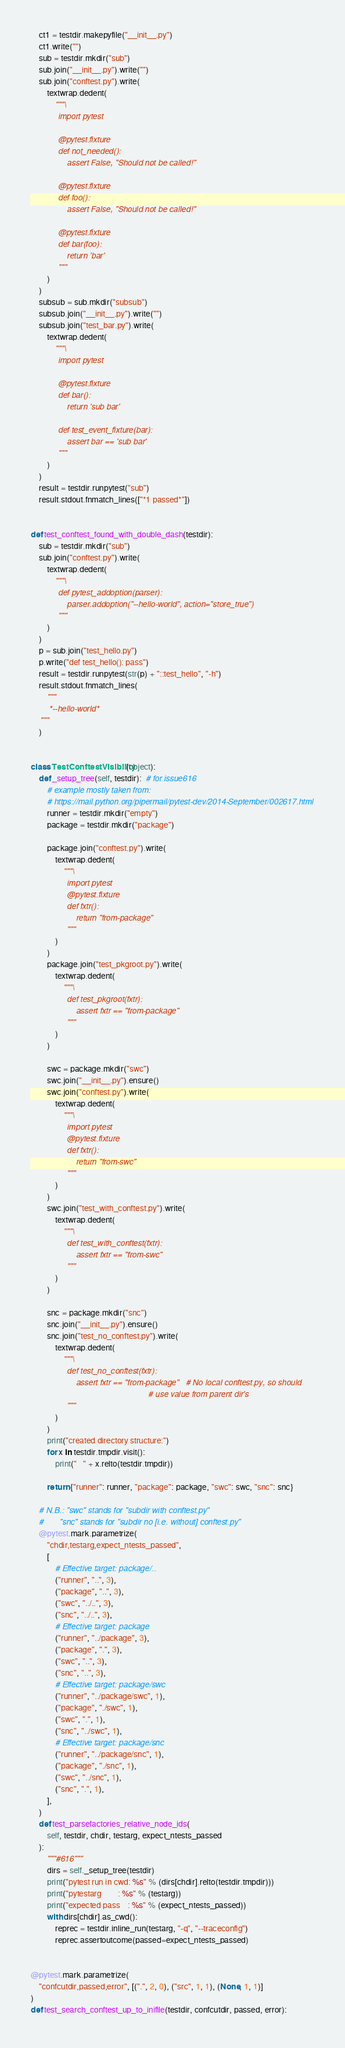Convert code to text. <code><loc_0><loc_0><loc_500><loc_500><_Python_>    ct1 = testdir.makepyfile("__init__.py")
    ct1.write("")
    sub = testdir.mkdir("sub")
    sub.join("__init__.py").write("")
    sub.join("conftest.py").write(
        textwrap.dedent(
            """\
            import pytest

            @pytest.fixture
            def not_needed():
                assert False, "Should not be called!"

            @pytest.fixture
            def foo():
                assert False, "Should not be called!"

            @pytest.fixture
            def bar(foo):
                return 'bar'
            """
        )
    )
    subsub = sub.mkdir("subsub")
    subsub.join("__init__.py").write("")
    subsub.join("test_bar.py").write(
        textwrap.dedent(
            """\
            import pytest

            @pytest.fixture
            def bar():
                return 'sub bar'

            def test_event_fixture(bar):
                assert bar == 'sub bar'
            """
        )
    )
    result = testdir.runpytest("sub")
    result.stdout.fnmatch_lines(["*1 passed*"])


def test_conftest_found_with_double_dash(testdir):
    sub = testdir.mkdir("sub")
    sub.join("conftest.py").write(
        textwrap.dedent(
            """\
            def pytest_addoption(parser):
                parser.addoption("--hello-world", action="store_true")
            """
        )
    )
    p = sub.join("test_hello.py")
    p.write("def test_hello(): pass")
    result = testdir.runpytest(str(p) + "::test_hello", "-h")
    result.stdout.fnmatch_lines(
        """
        *--hello-world*
    """
    )


class TestConftestVisibility(object):
    def _setup_tree(self, testdir):  # for issue616
        # example mostly taken from:
        # https://mail.python.org/pipermail/pytest-dev/2014-September/002617.html
        runner = testdir.mkdir("empty")
        package = testdir.mkdir("package")

        package.join("conftest.py").write(
            textwrap.dedent(
                """\
                import pytest
                @pytest.fixture
                def fxtr():
                    return "from-package"
                """
            )
        )
        package.join("test_pkgroot.py").write(
            textwrap.dedent(
                """\
                def test_pkgroot(fxtr):
                    assert fxtr == "from-package"
                """
            )
        )

        swc = package.mkdir("swc")
        swc.join("__init__.py").ensure()
        swc.join("conftest.py").write(
            textwrap.dedent(
                """\
                import pytest
                @pytest.fixture
                def fxtr():
                    return "from-swc"
                """
            )
        )
        swc.join("test_with_conftest.py").write(
            textwrap.dedent(
                """\
                def test_with_conftest(fxtr):
                    assert fxtr == "from-swc"
                """
            )
        )

        snc = package.mkdir("snc")
        snc.join("__init__.py").ensure()
        snc.join("test_no_conftest.py").write(
            textwrap.dedent(
                """\
                def test_no_conftest(fxtr):
                    assert fxtr == "from-package"   # No local conftest.py, so should
                                                    # use value from parent dir's
                """
            )
        )
        print("created directory structure:")
        for x in testdir.tmpdir.visit():
            print("   " + x.relto(testdir.tmpdir))

        return {"runner": runner, "package": package, "swc": swc, "snc": snc}

    # N.B.: "swc" stands for "subdir with conftest.py"
    #       "snc" stands for "subdir no [i.e. without] conftest.py"
    @pytest.mark.parametrize(
        "chdir,testarg,expect_ntests_passed",
        [
            # Effective target: package/..
            ("runner", "..", 3),
            ("package", "..", 3),
            ("swc", "../..", 3),
            ("snc", "../..", 3),
            # Effective target: package
            ("runner", "../package", 3),
            ("package", ".", 3),
            ("swc", "..", 3),
            ("snc", "..", 3),
            # Effective target: package/swc
            ("runner", "../package/swc", 1),
            ("package", "./swc", 1),
            ("swc", ".", 1),
            ("snc", "../swc", 1),
            # Effective target: package/snc
            ("runner", "../package/snc", 1),
            ("package", "./snc", 1),
            ("swc", "../snc", 1),
            ("snc", ".", 1),
        ],
    )
    def test_parsefactories_relative_node_ids(
        self, testdir, chdir, testarg, expect_ntests_passed
    ):
        """#616"""
        dirs = self._setup_tree(testdir)
        print("pytest run in cwd: %s" % (dirs[chdir].relto(testdir.tmpdir)))
        print("pytestarg        : %s" % (testarg))
        print("expected pass    : %s" % (expect_ntests_passed))
        with dirs[chdir].as_cwd():
            reprec = testdir.inline_run(testarg, "-q", "--traceconfig")
            reprec.assertoutcome(passed=expect_ntests_passed)


@pytest.mark.parametrize(
    "confcutdir,passed,error", [(".", 2, 0), ("src", 1, 1), (None, 1, 1)]
)
def test_search_conftest_up_to_inifile(testdir, confcutdir, passed, error):</code> 